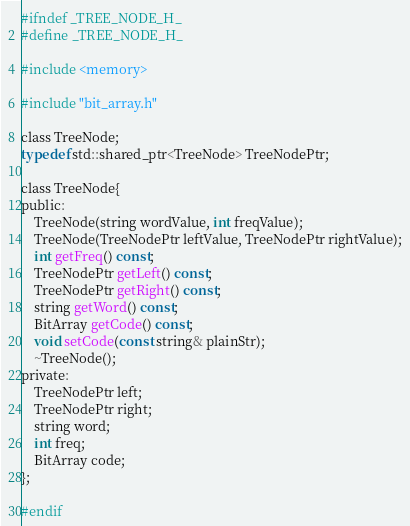Convert code to text. <code><loc_0><loc_0><loc_500><loc_500><_C_>
#ifndef _TREE_NODE_H_
#define _TREE_NODE_H_

#include <memory>

#include "bit_array.h"

class TreeNode;
typedef std::shared_ptr<TreeNode> TreeNodePtr;

class TreeNode{
public:
    TreeNode(string wordValue, int freqValue);
    TreeNode(TreeNodePtr leftValue, TreeNodePtr rightValue);
    int getFreq() const;
    TreeNodePtr getLeft() const;
    TreeNodePtr getRight() const;
    string getWord() const;
    BitArray getCode() const;
    void setCode(const string& plainStr);
    ~TreeNode();
private:
    TreeNodePtr left;
    TreeNodePtr right;
    string word;
    int freq;
    BitArray code;
};

#endif
</code> 